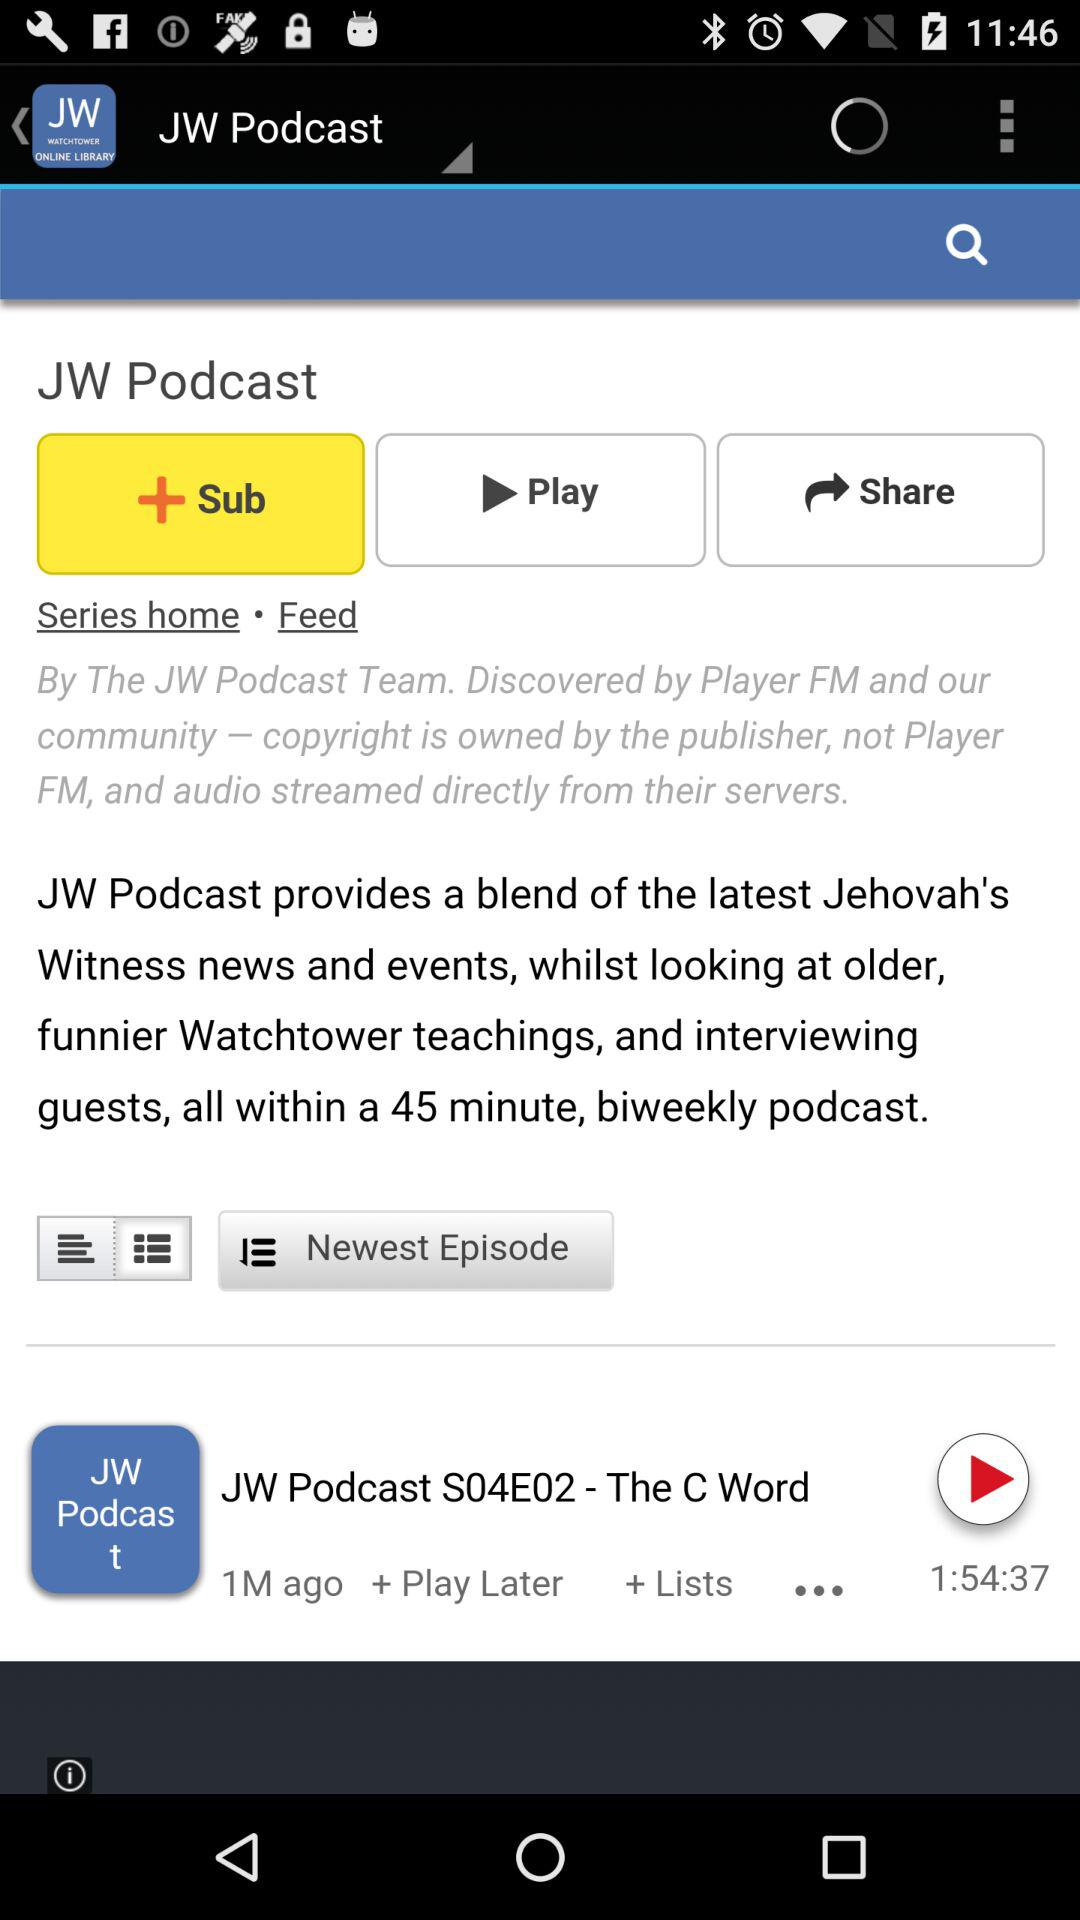Which episode is playing? The episode is "JW Podcast S04E02 - The C Word". 